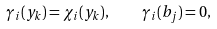<formula> <loc_0><loc_0><loc_500><loc_500>\gamma _ { i } ( y _ { k } ) = \chi _ { i } ( y _ { k } ) , \quad \gamma _ { i } ( b _ { j } ) = 0 ,</formula> 